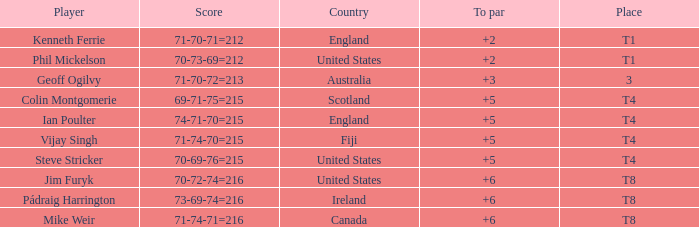Who was the player positioned at t1 in to par with a total score of 70-73-69=212? 2.0. 